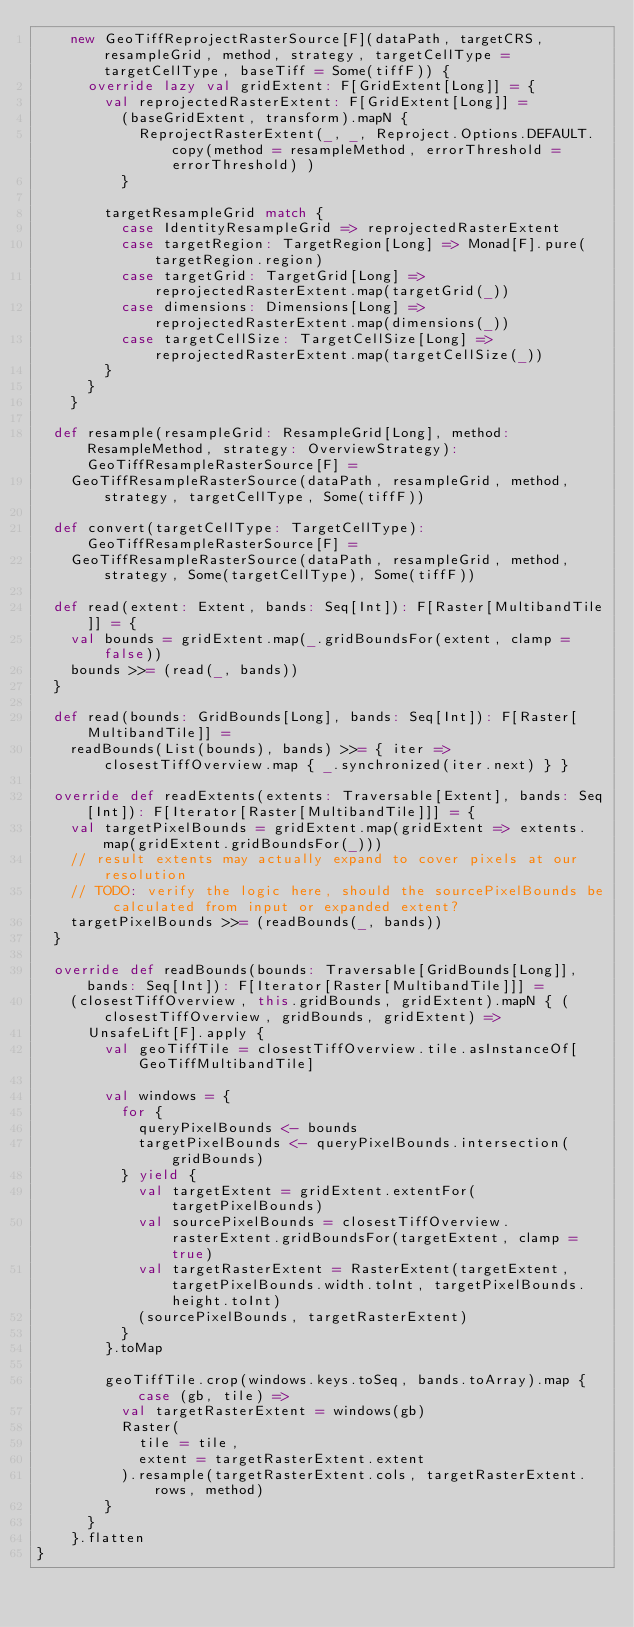Convert code to text. <code><loc_0><loc_0><loc_500><loc_500><_Scala_>    new GeoTiffReprojectRasterSource[F](dataPath, targetCRS, resampleGrid, method, strategy, targetCellType = targetCellType, baseTiff = Some(tiffF)) {
      override lazy val gridExtent: F[GridExtent[Long]] = {
        val reprojectedRasterExtent: F[GridExtent[Long]] =
          (baseGridExtent, transform).mapN {
            ReprojectRasterExtent(_, _, Reproject.Options.DEFAULT.copy(method = resampleMethod, errorThreshold = errorThreshold) )
          }

        targetResampleGrid match {
          case IdentityResampleGrid => reprojectedRasterExtent
          case targetRegion: TargetRegion[Long] => Monad[F].pure(targetRegion.region)
          case targetGrid: TargetGrid[Long] => reprojectedRasterExtent.map(targetGrid(_))
          case dimensions: Dimensions[Long] => reprojectedRasterExtent.map(dimensions(_))
          case targetCellSize: TargetCellSize[Long] => reprojectedRasterExtent.map(targetCellSize(_))
        }
      }
    }

  def resample(resampleGrid: ResampleGrid[Long], method: ResampleMethod, strategy: OverviewStrategy): GeoTiffResampleRasterSource[F] =
    GeoTiffResampleRasterSource(dataPath, resampleGrid, method, strategy, targetCellType, Some(tiffF))

  def convert(targetCellType: TargetCellType): GeoTiffResampleRasterSource[F] =
    GeoTiffResampleRasterSource(dataPath, resampleGrid, method, strategy, Some(targetCellType), Some(tiffF))

  def read(extent: Extent, bands: Seq[Int]): F[Raster[MultibandTile]] = {
    val bounds = gridExtent.map(_.gridBoundsFor(extent, clamp = false))
    bounds >>= (read(_, bands))
  }

  def read(bounds: GridBounds[Long], bands: Seq[Int]): F[Raster[MultibandTile]] =
    readBounds(List(bounds), bands) >>= { iter => closestTiffOverview.map { _.synchronized(iter.next) } }

  override def readExtents(extents: Traversable[Extent], bands: Seq[Int]): F[Iterator[Raster[MultibandTile]]] = {
    val targetPixelBounds = gridExtent.map(gridExtent => extents.map(gridExtent.gridBoundsFor(_)))
    // result extents may actually expand to cover pixels at our resolution
    // TODO: verify the logic here, should the sourcePixelBounds be calculated from input or expanded extent?
    targetPixelBounds >>= (readBounds(_, bands))
  }

  override def readBounds(bounds: Traversable[GridBounds[Long]], bands: Seq[Int]): F[Iterator[Raster[MultibandTile]]] =
    (closestTiffOverview, this.gridBounds, gridExtent).mapN { (closestTiffOverview, gridBounds, gridExtent) =>
      UnsafeLift[F].apply {
        val geoTiffTile = closestTiffOverview.tile.asInstanceOf[GeoTiffMultibandTile]

        val windows = {
          for {
            queryPixelBounds <- bounds
            targetPixelBounds <- queryPixelBounds.intersection(gridBounds)
          } yield {
            val targetExtent = gridExtent.extentFor(targetPixelBounds)
            val sourcePixelBounds = closestTiffOverview.rasterExtent.gridBoundsFor(targetExtent, clamp = true)
            val targetRasterExtent = RasterExtent(targetExtent, targetPixelBounds.width.toInt, targetPixelBounds.height.toInt)
            (sourcePixelBounds, targetRasterExtent)
          }
        }.toMap

        geoTiffTile.crop(windows.keys.toSeq, bands.toArray).map { case (gb, tile) =>
          val targetRasterExtent = windows(gb)
          Raster(
            tile = tile,
            extent = targetRasterExtent.extent
          ).resample(targetRasterExtent.cols, targetRasterExtent.rows, method)
        }
      }
    }.flatten
}
</code> 